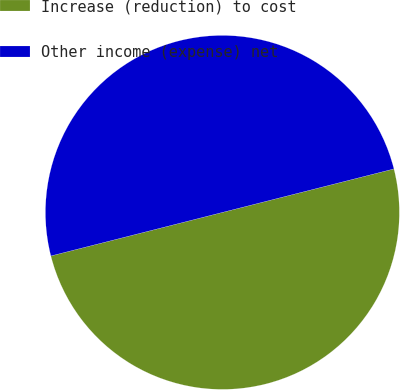Convert chart to OTSL. <chart><loc_0><loc_0><loc_500><loc_500><pie_chart><fcel>Increase (reduction) to cost<fcel>Other income (expense) net<nl><fcel>50.0%<fcel>50.0%<nl></chart> 